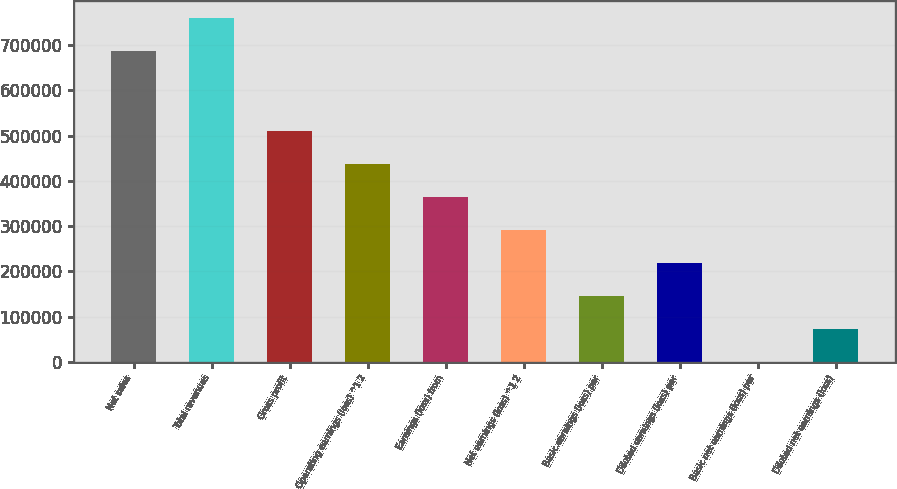<chart> <loc_0><loc_0><loc_500><loc_500><bar_chart><fcel>Net sales<fcel>Total revenues<fcel>Gross profit<fcel>Operating earnings (loss) ^1 2<fcel>Earnings (loss) from<fcel>Net earnings (loss) ^1 2<fcel>Basic earnings (loss) per<fcel>Diluted earnings (loss) per<fcel>Basic net earnings (loss) per<fcel>Diluted net earnings (loss)<nl><fcel>687616<fcel>760502<fcel>510203<fcel>437317<fcel>364431<fcel>291544<fcel>145772<fcel>218658<fcel>0.11<fcel>72886.2<nl></chart> 